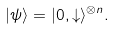Convert formula to latex. <formula><loc_0><loc_0><loc_500><loc_500>| \psi \rangle = | 0 , \downarrow \rangle ^ { \otimes n } .</formula> 